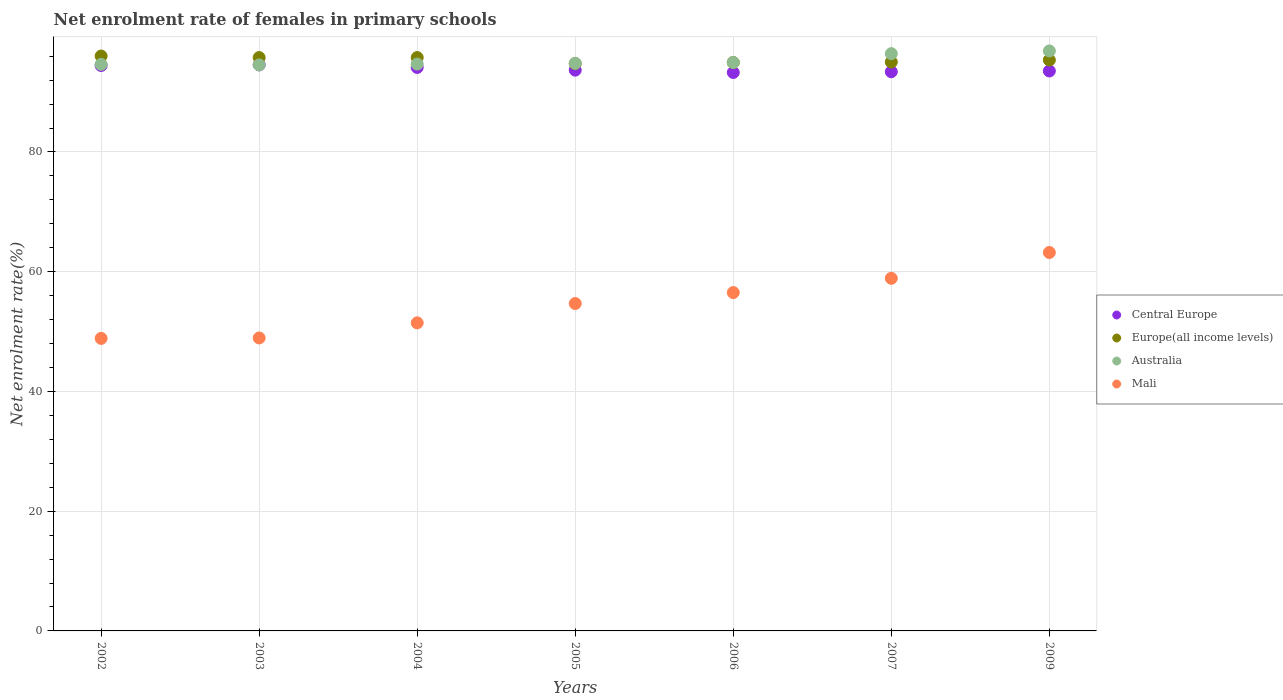How many different coloured dotlines are there?
Give a very brief answer. 4. What is the net enrolment rate of females in primary schools in Europe(all income levels) in 2007?
Give a very brief answer. 95.02. Across all years, what is the maximum net enrolment rate of females in primary schools in Australia?
Your answer should be very brief. 96.88. Across all years, what is the minimum net enrolment rate of females in primary schools in Mali?
Give a very brief answer. 48.86. In which year was the net enrolment rate of females in primary schools in Australia minimum?
Your response must be concise. 2003. What is the total net enrolment rate of females in primary schools in Mali in the graph?
Provide a short and direct response. 382.57. What is the difference between the net enrolment rate of females in primary schools in Central Europe in 2003 and that in 2006?
Your response must be concise. 1.27. What is the difference between the net enrolment rate of females in primary schools in Europe(all income levels) in 2004 and the net enrolment rate of females in primary schools in Australia in 2007?
Provide a short and direct response. -0.65. What is the average net enrolment rate of females in primary schools in Central Europe per year?
Keep it short and to the point. 93.86. In the year 2007, what is the difference between the net enrolment rate of females in primary schools in Central Europe and net enrolment rate of females in primary schools in Australia?
Make the answer very short. -3.02. In how many years, is the net enrolment rate of females in primary schools in Mali greater than 80 %?
Provide a short and direct response. 0. What is the ratio of the net enrolment rate of females in primary schools in Europe(all income levels) in 2005 to that in 2006?
Offer a very short reply. 1. What is the difference between the highest and the second highest net enrolment rate of females in primary schools in Mali?
Provide a succinct answer. 4.31. What is the difference between the highest and the lowest net enrolment rate of females in primary schools in Mali?
Keep it short and to the point. 14.35. Is it the case that in every year, the sum of the net enrolment rate of females in primary schools in Mali and net enrolment rate of females in primary schools in Australia  is greater than the sum of net enrolment rate of females in primary schools in Europe(all income levels) and net enrolment rate of females in primary schools in Central Europe?
Make the answer very short. No. Does the net enrolment rate of females in primary schools in Europe(all income levels) monotonically increase over the years?
Keep it short and to the point. No. How many dotlines are there?
Provide a short and direct response. 4. How many years are there in the graph?
Your answer should be very brief. 7. How many legend labels are there?
Give a very brief answer. 4. How are the legend labels stacked?
Offer a very short reply. Vertical. What is the title of the graph?
Offer a very short reply. Net enrolment rate of females in primary schools. What is the label or title of the X-axis?
Provide a short and direct response. Years. What is the label or title of the Y-axis?
Your answer should be very brief. Net enrolment rate(%). What is the Net enrolment rate(%) of Central Europe in 2002?
Offer a terse response. 94.44. What is the Net enrolment rate(%) in Europe(all income levels) in 2002?
Provide a succinct answer. 96.03. What is the Net enrolment rate(%) of Australia in 2002?
Your response must be concise. 94.64. What is the Net enrolment rate(%) of Mali in 2002?
Give a very brief answer. 48.86. What is the Net enrolment rate(%) in Central Europe in 2003?
Provide a succinct answer. 94.55. What is the Net enrolment rate(%) in Europe(all income levels) in 2003?
Your answer should be compact. 95.77. What is the Net enrolment rate(%) of Australia in 2003?
Keep it short and to the point. 94.54. What is the Net enrolment rate(%) of Mali in 2003?
Offer a terse response. 48.93. What is the Net enrolment rate(%) of Central Europe in 2004?
Provide a succinct answer. 94.12. What is the Net enrolment rate(%) of Europe(all income levels) in 2004?
Your response must be concise. 95.78. What is the Net enrolment rate(%) in Australia in 2004?
Offer a very short reply. 94.69. What is the Net enrolment rate(%) in Mali in 2004?
Provide a succinct answer. 51.46. What is the Net enrolment rate(%) in Central Europe in 2005?
Provide a succinct answer. 93.67. What is the Net enrolment rate(%) in Europe(all income levels) in 2005?
Your answer should be compact. 94.78. What is the Net enrolment rate(%) in Australia in 2005?
Keep it short and to the point. 94.81. What is the Net enrolment rate(%) in Mali in 2005?
Your response must be concise. 54.69. What is the Net enrolment rate(%) in Central Europe in 2006?
Offer a terse response. 93.28. What is the Net enrolment rate(%) in Europe(all income levels) in 2006?
Give a very brief answer. 94.96. What is the Net enrolment rate(%) in Australia in 2006?
Your answer should be compact. 94.95. What is the Net enrolment rate(%) of Mali in 2006?
Offer a very short reply. 56.52. What is the Net enrolment rate(%) of Central Europe in 2007?
Provide a succinct answer. 93.4. What is the Net enrolment rate(%) in Europe(all income levels) in 2007?
Your answer should be compact. 95.02. What is the Net enrolment rate(%) in Australia in 2007?
Provide a short and direct response. 96.43. What is the Net enrolment rate(%) of Mali in 2007?
Offer a terse response. 58.9. What is the Net enrolment rate(%) of Central Europe in 2009?
Provide a succinct answer. 93.53. What is the Net enrolment rate(%) of Europe(all income levels) in 2009?
Your response must be concise. 95.35. What is the Net enrolment rate(%) of Australia in 2009?
Your response must be concise. 96.88. What is the Net enrolment rate(%) of Mali in 2009?
Keep it short and to the point. 63.21. Across all years, what is the maximum Net enrolment rate(%) in Central Europe?
Make the answer very short. 94.55. Across all years, what is the maximum Net enrolment rate(%) in Europe(all income levels)?
Offer a terse response. 96.03. Across all years, what is the maximum Net enrolment rate(%) of Australia?
Offer a terse response. 96.88. Across all years, what is the maximum Net enrolment rate(%) of Mali?
Keep it short and to the point. 63.21. Across all years, what is the minimum Net enrolment rate(%) in Central Europe?
Offer a very short reply. 93.28. Across all years, what is the minimum Net enrolment rate(%) of Europe(all income levels)?
Give a very brief answer. 94.78. Across all years, what is the minimum Net enrolment rate(%) of Australia?
Provide a short and direct response. 94.54. Across all years, what is the minimum Net enrolment rate(%) of Mali?
Make the answer very short. 48.86. What is the total Net enrolment rate(%) of Central Europe in the graph?
Ensure brevity in your answer.  656.99. What is the total Net enrolment rate(%) in Europe(all income levels) in the graph?
Your answer should be compact. 667.68. What is the total Net enrolment rate(%) of Australia in the graph?
Provide a short and direct response. 666.92. What is the total Net enrolment rate(%) of Mali in the graph?
Your response must be concise. 382.57. What is the difference between the Net enrolment rate(%) in Central Europe in 2002 and that in 2003?
Offer a very short reply. -0.11. What is the difference between the Net enrolment rate(%) in Europe(all income levels) in 2002 and that in 2003?
Your answer should be very brief. 0.26. What is the difference between the Net enrolment rate(%) in Australia in 2002 and that in 2003?
Your response must be concise. 0.1. What is the difference between the Net enrolment rate(%) in Mali in 2002 and that in 2003?
Provide a succinct answer. -0.07. What is the difference between the Net enrolment rate(%) in Central Europe in 2002 and that in 2004?
Ensure brevity in your answer.  0.32. What is the difference between the Net enrolment rate(%) in Europe(all income levels) in 2002 and that in 2004?
Provide a short and direct response. 0.25. What is the difference between the Net enrolment rate(%) in Australia in 2002 and that in 2004?
Your response must be concise. -0.05. What is the difference between the Net enrolment rate(%) in Mali in 2002 and that in 2004?
Your response must be concise. -2.6. What is the difference between the Net enrolment rate(%) in Central Europe in 2002 and that in 2005?
Make the answer very short. 0.77. What is the difference between the Net enrolment rate(%) of Europe(all income levels) in 2002 and that in 2005?
Your answer should be compact. 1.25. What is the difference between the Net enrolment rate(%) of Australia in 2002 and that in 2005?
Keep it short and to the point. -0.17. What is the difference between the Net enrolment rate(%) in Mali in 2002 and that in 2005?
Your answer should be compact. -5.82. What is the difference between the Net enrolment rate(%) of Central Europe in 2002 and that in 2006?
Offer a terse response. 1.16. What is the difference between the Net enrolment rate(%) of Europe(all income levels) in 2002 and that in 2006?
Provide a succinct answer. 1.07. What is the difference between the Net enrolment rate(%) in Australia in 2002 and that in 2006?
Provide a succinct answer. -0.31. What is the difference between the Net enrolment rate(%) in Mali in 2002 and that in 2006?
Your answer should be very brief. -7.65. What is the difference between the Net enrolment rate(%) in Central Europe in 2002 and that in 2007?
Provide a short and direct response. 1.04. What is the difference between the Net enrolment rate(%) in Australia in 2002 and that in 2007?
Provide a short and direct response. -1.79. What is the difference between the Net enrolment rate(%) of Mali in 2002 and that in 2007?
Your answer should be compact. -10.04. What is the difference between the Net enrolment rate(%) in Central Europe in 2002 and that in 2009?
Your answer should be compact. 0.92. What is the difference between the Net enrolment rate(%) of Europe(all income levels) in 2002 and that in 2009?
Your answer should be compact. 0.67. What is the difference between the Net enrolment rate(%) in Australia in 2002 and that in 2009?
Provide a short and direct response. -2.24. What is the difference between the Net enrolment rate(%) of Mali in 2002 and that in 2009?
Your response must be concise. -14.35. What is the difference between the Net enrolment rate(%) of Central Europe in 2003 and that in 2004?
Your answer should be compact. 0.43. What is the difference between the Net enrolment rate(%) of Europe(all income levels) in 2003 and that in 2004?
Your answer should be compact. -0. What is the difference between the Net enrolment rate(%) of Australia in 2003 and that in 2004?
Give a very brief answer. -0.14. What is the difference between the Net enrolment rate(%) of Mali in 2003 and that in 2004?
Provide a succinct answer. -2.52. What is the difference between the Net enrolment rate(%) of Central Europe in 2003 and that in 2005?
Provide a short and direct response. 0.88. What is the difference between the Net enrolment rate(%) of Australia in 2003 and that in 2005?
Keep it short and to the point. -0.27. What is the difference between the Net enrolment rate(%) in Mali in 2003 and that in 2005?
Provide a succinct answer. -5.75. What is the difference between the Net enrolment rate(%) in Central Europe in 2003 and that in 2006?
Provide a succinct answer. 1.27. What is the difference between the Net enrolment rate(%) in Europe(all income levels) in 2003 and that in 2006?
Make the answer very short. 0.81. What is the difference between the Net enrolment rate(%) in Australia in 2003 and that in 2006?
Offer a terse response. -0.41. What is the difference between the Net enrolment rate(%) in Mali in 2003 and that in 2006?
Your response must be concise. -7.58. What is the difference between the Net enrolment rate(%) of Central Europe in 2003 and that in 2007?
Keep it short and to the point. 1.14. What is the difference between the Net enrolment rate(%) of Europe(all income levels) in 2003 and that in 2007?
Provide a short and direct response. 0.75. What is the difference between the Net enrolment rate(%) of Australia in 2003 and that in 2007?
Give a very brief answer. -1.88. What is the difference between the Net enrolment rate(%) of Mali in 2003 and that in 2007?
Ensure brevity in your answer.  -9.96. What is the difference between the Net enrolment rate(%) of Central Europe in 2003 and that in 2009?
Make the answer very short. 1.02. What is the difference between the Net enrolment rate(%) of Europe(all income levels) in 2003 and that in 2009?
Offer a very short reply. 0.42. What is the difference between the Net enrolment rate(%) of Australia in 2003 and that in 2009?
Keep it short and to the point. -2.33. What is the difference between the Net enrolment rate(%) of Mali in 2003 and that in 2009?
Your response must be concise. -14.28. What is the difference between the Net enrolment rate(%) of Central Europe in 2004 and that in 2005?
Your response must be concise. 0.45. What is the difference between the Net enrolment rate(%) in Europe(all income levels) in 2004 and that in 2005?
Your answer should be very brief. 1. What is the difference between the Net enrolment rate(%) of Australia in 2004 and that in 2005?
Offer a terse response. -0.12. What is the difference between the Net enrolment rate(%) of Mali in 2004 and that in 2005?
Your answer should be compact. -3.23. What is the difference between the Net enrolment rate(%) in Central Europe in 2004 and that in 2006?
Ensure brevity in your answer.  0.84. What is the difference between the Net enrolment rate(%) in Europe(all income levels) in 2004 and that in 2006?
Offer a terse response. 0.82. What is the difference between the Net enrolment rate(%) of Australia in 2004 and that in 2006?
Your answer should be very brief. -0.26. What is the difference between the Net enrolment rate(%) of Mali in 2004 and that in 2006?
Give a very brief answer. -5.06. What is the difference between the Net enrolment rate(%) of Central Europe in 2004 and that in 2007?
Offer a terse response. 0.72. What is the difference between the Net enrolment rate(%) in Europe(all income levels) in 2004 and that in 2007?
Provide a succinct answer. 0.75. What is the difference between the Net enrolment rate(%) of Australia in 2004 and that in 2007?
Provide a short and direct response. -1.74. What is the difference between the Net enrolment rate(%) of Mali in 2004 and that in 2007?
Make the answer very short. -7.44. What is the difference between the Net enrolment rate(%) of Central Europe in 2004 and that in 2009?
Offer a very short reply. 0.59. What is the difference between the Net enrolment rate(%) in Europe(all income levels) in 2004 and that in 2009?
Offer a very short reply. 0.42. What is the difference between the Net enrolment rate(%) of Australia in 2004 and that in 2009?
Provide a short and direct response. -2.19. What is the difference between the Net enrolment rate(%) of Mali in 2004 and that in 2009?
Make the answer very short. -11.75. What is the difference between the Net enrolment rate(%) in Central Europe in 2005 and that in 2006?
Make the answer very short. 0.39. What is the difference between the Net enrolment rate(%) of Europe(all income levels) in 2005 and that in 2006?
Your answer should be compact. -0.18. What is the difference between the Net enrolment rate(%) in Australia in 2005 and that in 2006?
Make the answer very short. -0.14. What is the difference between the Net enrolment rate(%) in Mali in 2005 and that in 2006?
Ensure brevity in your answer.  -1.83. What is the difference between the Net enrolment rate(%) of Central Europe in 2005 and that in 2007?
Offer a terse response. 0.26. What is the difference between the Net enrolment rate(%) in Europe(all income levels) in 2005 and that in 2007?
Offer a terse response. -0.25. What is the difference between the Net enrolment rate(%) in Australia in 2005 and that in 2007?
Offer a very short reply. -1.62. What is the difference between the Net enrolment rate(%) of Mali in 2005 and that in 2007?
Your answer should be compact. -4.21. What is the difference between the Net enrolment rate(%) in Central Europe in 2005 and that in 2009?
Your response must be concise. 0.14. What is the difference between the Net enrolment rate(%) in Europe(all income levels) in 2005 and that in 2009?
Offer a terse response. -0.58. What is the difference between the Net enrolment rate(%) in Australia in 2005 and that in 2009?
Your answer should be compact. -2.07. What is the difference between the Net enrolment rate(%) in Mali in 2005 and that in 2009?
Offer a very short reply. -8.52. What is the difference between the Net enrolment rate(%) in Central Europe in 2006 and that in 2007?
Your answer should be very brief. -0.13. What is the difference between the Net enrolment rate(%) of Europe(all income levels) in 2006 and that in 2007?
Your response must be concise. -0.07. What is the difference between the Net enrolment rate(%) of Australia in 2006 and that in 2007?
Your answer should be compact. -1.48. What is the difference between the Net enrolment rate(%) in Mali in 2006 and that in 2007?
Ensure brevity in your answer.  -2.38. What is the difference between the Net enrolment rate(%) of Central Europe in 2006 and that in 2009?
Provide a succinct answer. -0.25. What is the difference between the Net enrolment rate(%) of Europe(all income levels) in 2006 and that in 2009?
Offer a very short reply. -0.4. What is the difference between the Net enrolment rate(%) in Australia in 2006 and that in 2009?
Provide a succinct answer. -1.93. What is the difference between the Net enrolment rate(%) of Mali in 2006 and that in 2009?
Offer a terse response. -6.69. What is the difference between the Net enrolment rate(%) of Central Europe in 2007 and that in 2009?
Your response must be concise. -0.12. What is the difference between the Net enrolment rate(%) of Europe(all income levels) in 2007 and that in 2009?
Your response must be concise. -0.33. What is the difference between the Net enrolment rate(%) in Australia in 2007 and that in 2009?
Your answer should be very brief. -0.45. What is the difference between the Net enrolment rate(%) in Mali in 2007 and that in 2009?
Offer a very short reply. -4.31. What is the difference between the Net enrolment rate(%) of Central Europe in 2002 and the Net enrolment rate(%) of Europe(all income levels) in 2003?
Provide a short and direct response. -1.33. What is the difference between the Net enrolment rate(%) of Central Europe in 2002 and the Net enrolment rate(%) of Australia in 2003?
Provide a short and direct response. -0.1. What is the difference between the Net enrolment rate(%) in Central Europe in 2002 and the Net enrolment rate(%) in Mali in 2003?
Ensure brevity in your answer.  45.51. What is the difference between the Net enrolment rate(%) in Europe(all income levels) in 2002 and the Net enrolment rate(%) in Australia in 2003?
Provide a short and direct response. 1.49. What is the difference between the Net enrolment rate(%) in Europe(all income levels) in 2002 and the Net enrolment rate(%) in Mali in 2003?
Provide a short and direct response. 47.09. What is the difference between the Net enrolment rate(%) of Australia in 2002 and the Net enrolment rate(%) of Mali in 2003?
Give a very brief answer. 45.7. What is the difference between the Net enrolment rate(%) of Central Europe in 2002 and the Net enrolment rate(%) of Europe(all income levels) in 2004?
Offer a very short reply. -1.33. What is the difference between the Net enrolment rate(%) of Central Europe in 2002 and the Net enrolment rate(%) of Australia in 2004?
Provide a succinct answer. -0.24. What is the difference between the Net enrolment rate(%) of Central Europe in 2002 and the Net enrolment rate(%) of Mali in 2004?
Your response must be concise. 42.98. What is the difference between the Net enrolment rate(%) in Europe(all income levels) in 2002 and the Net enrolment rate(%) in Australia in 2004?
Your answer should be very brief. 1.34. What is the difference between the Net enrolment rate(%) in Europe(all income levels) in 2002 and the Net enrolment rate(%) in Mali in 2004?
Your response must be concise. 44.57. What is the difference between the Net enrolment rate(%) of Australia in 2002 and the Net enrolment rate(%) of Mali in 2004?
Provide a succinct answer. 43.18. What is the difference between the Net enrolment rate(%) of Central Europe in 2002 and the Net enrolment rate(%) of Europe(all income levels) in 2005?
Your response must be concise. -0.33. What is the difference between the Net enrolment rate(%) of Central Europe in 2002 and the Net enrolment rate(%) of Australia in 2005?
Ensure brevity in your answer.  -0.36. What is the difference between the Net enrolment rate(%) of Central Europe in 2002 and the Net enrolment rate(%) of Mali in 2005?
Provide a succinct answer. 39.76. What is the difference between the Net enrolment rate(%) in Europe(all income levels) in 2002 and the Net enrolment rate(%) in Australia in 2005?
Offer a terse response. 1.22. What is the difference between the Net enrolment rate(%) of Europe(all income levels) in 2002 and the Net enrolment rate(%) of Mali in 2005?
Offer a terse response. 41.34. What is the difference between the Net enrolment rate(%) in Australia in 2002 and the Net enrolment rate(%) in Mali in 2005?
Ensure brevity in your answer.  39.95. What is the difference between the Net enrolment rate(%) of Central Europe in 2002 and the Net enrolment rate(%) of Europe(all income levels) in 2006?
Make the answer very short. -0.51. What is the difference between the Net enrolment rate(%) in Central Europe in 2002 and the Net enrolment rate(%) in Australia in 2006?
Offer a terse response. -0.5. What is the difference between the Net enrolment rate(%) in Central Europe in 2002 and the Net enrolment rate(%) in Mali in 2006?
Your answer should be very brief. 37.93. What is the difference between the Net enrolment rate(%) in Europe(all income levels) in 2002 and the Net enrolment rate(%) in Australia in 2006?
Offer a very short reply. 1.08. What is the difference between the Net enrolment rate(%) of Europe(all income levels) in 2002 and the Net enrolment rate(%) of Mali in 2006?
Your answer should be compact. 39.51. What is the difference between the Net enrolment rate(%) of Australia in 2002 and the Net enrolment rate(%) of Mali in 2006?
Your answer should be compact. 38.12. What is the difference between the Net enrolment rate(%) of Central Europe in 2002 and the Net enrolment rate(%) of Europe(all income levels) in 2007?
Keep it short and to the point. -0.58. What is the difference between the Net enrolment rate(%) of Central Europe in 2002 and the Net enrolment rate(%) of Australia in 2007?
Keep it short and to the point. -1.98. What is the difference between the Net enrolment rate(%) in Central Europe in 2002 and the Net enrolment rate(%) in Mali in 2007?
Your answer should be compact. 35.55. What is the difference between the Net enrolment rate(%) of Europe(all income levels) in 2002 and the Net enrolment rate(%) of Australia in 2007?
Provide a short and direct response. -0.4. What is the difference between the Net enrolment rate(%) in Europe(all income levels) in 2002 and the Net enrolment rate(%) in Mali in 2007?
Provide a short and direct response. 37.13. What is the difference between the Net enrolment rate(%) of Australia in 2002 and the Net enrolment rate(%) of Mali in 2007?
Your answer should be compact. 35.74. What is the difference between the Net enrolment rate(%) of Central Europe in 2002 and the Net enrolment rate(%) of Europe(all income levels) in 2009?
Offer a terse response. -0.91. What is the difference between the Net enrolment rate(%) of Central Europe in 2002 and the Net enrolment rate(%) of Australia in 2009?
Give a very brief answer. -2.43. What is the difference between the Net enrolment rate(%) of Central Europe in 2002 and the Net enrolment rate(%) of Mali in 2009?
Offer a very short reply. 31.23. What is the difference between the Net enrolment rate(%) of Europe(all income levels) in 2002 and the Net enrolment rate(%) of Australia in 2009?
Make the answer very short. -0.85. What is the difference between the Net enrolment rate(%) of Europe(all income levels) in 2002 and the Net enrolment rate(%) of Mali in 2009?
Your answer should be very brief. 32.82. What is the difference between the Net enrolment rate(%) in Australia in 2002 and the Net enrolment rate(%) in Mali in 2009?
Give a very brief answer. 31.43. What is the difference between the Net enrolment rate(%) in Central Europe in 2003 and the Net enrolment rate(%) in Europe(all income levels) in 2004?
Your answer should be compact. -1.23. What is the difference between the Net enrolment rate(%) of Central Europe in 2003 and the Net enrolment rate(%) of Australia in 2004?
Your answer should be compact. -0.14. What is the difference between the Net enrolment rate(%) in Central Europe in 2003 and the Net enrolment rate(%) in Mali in 2004?
Make the answer very short. 43.09. What is the difference between the Net enrolment rate(%) of Europe(all income levels) in 2003 and the Net enrolment rate(%) of Australia in 2004?
Offer a terse response. 1.09. What is the difference between the Net enrolment rate(%) in Europe(all income levels) in 2003 and the Net enrolment rate(%) in Mali in 2004?
Your response must be concise. 44.31. What is the difference between the Net enrolment rate(%) in Australia in 2003 and the Net enrolment rate(%) in Mali in 2004?
Your answer should be very brief. 43.08. What is the difference between the Net enrolment rate(%) in Central Europe in 2003 and the Net enrolment rate(%) in Europe(all income levels) in 2005?
Offer a very short reply. -0.23. What is the difference between the Net enrolment rate(%) in Central Europe in 2003 and the Net enrolment rate(%) in Australia in 2005?
Give a very brief answer. -0.26. What is the difference between the Net enrolment rate(%) of Central Europe in 2003 and the Net enrolment rate(%) of Mali in 2005?
Ensure brevity in your answer.  39.86. What is the difference between the Net enrolment rate(%) of Europe(all income levels) in 2003 and the Net enrolment rate(%) of Australia in 2005?
Give a very brief answer. 0.96. What is the difference between the Net enrolment rate(%) of Europe(all income levels) in 2003 and the Net enrolment rate(%) of Mali in 2005?
Make the answer very short. 41.08. What is the difference between the Net enrolment rate(%) in Australia in 2003 and the Net enrolment rate(%) in Mali in 2005?
Provide a succinct answer. 39.85. What is the difference between the Net enrolment rate(%) in Central Europe in 2003 and the Net enrolment rate(%) in Europe(all income levels) in 2006?
Keep it short and to the point. -0.41. What is the difference between the Net enrolment rate(%) in Central Europe in 2003 and the Net enrolment rate(%) in Australia in 2006?
Give a very brief answer. -0.4. What is the difference between the Net enrolment rate(%) in Central Europe in 2003 and the Net enrolment rate(%) in Mali in 2006?
Provide a succinct answer. 38.03. What is the difference between the Net enrolment rate(%) of Europe(all income levels) in 2003 and the Net enrolment rate(%) of Australia in 2006?
Provide a short and direct response. 0.82. What is the difference between the Net enrolment rate(%) in Europe(all income levels) in 2003 and the Net enrolment rate(%) in Mali in 2006?
Your response must be concise. 39.25. What is the difference between the Net enrolment rate(%) of Australia in 2003 and the Net enrolment rate(%) of Mali in 2006?
Make the answer very short. 38.03. What is the difference between the Net enrolment rate(%) in Central Europe in 2003 and the Net enrolment rate(%) in Europe(all income levels) in 2007?
Offer a terse response. -0.48. What is the difference between the Net enrolment rate(%) in Central Europe in 2003 and the Net enrolment rate(%) in Australia in 2007?
Offer a very short reply. -1.88. What is the difference between the Net enrolment rate(%) in Central Europe in 2003 and the Net enrolment rate(%) in Mali in 2007?
Make the answer very short. 35.65. What is the difference between the Net enrolment rate(%) in Europe(all income levels) in 2003 and the Net enrolment rate(%) in Australia in 2007?
Give a very brief answer. -0.65. What is the difference between the Net enrolment rate(%) in Europe(all income levels) in 2003 and the Net enrolment rate(%) in Mali in 2007?
Keep it short and to the point. 36.87. What is the difference between the Net enrolment rate(%) of Australia in 2003 and the Net enrolment rate(%) of Mali in 2007?
Provide a succinct answer. 35.64. What is the difference between the Net enrolment rate(%) of Central Europe in 2003 and the Net enrolment rate(%) of Europe(all income levels) in 2009?
Offer a terse response. -0.81. What is the difference between the Net enrolment rate(%) in Central Europe in 2003 and the Net enrolment rate(%) in Australia in 2009?
Make the answer very short. -2.33. What is the difference between the Net enrolment rate(%) of Central Europe in 2003 and the Net enrolment rate(%) of Mali in 2009?
Your response must be concise. 31.34. What is the difference between the Net enrolment rate(%) in Europe(all income levels) in 2003 and the Net enrolment rate(%) in Australia in 2009?
Your answer should be very brief. -1.1. What is the difference between the Net enrolment rate(%) in Europe(all income levels) in 2003 and the Net enrolment rate(%) in Mali in 2009?
Your answer should be very brief. 32.56. What is the difference between the Net enrolment rate(%) of Australia in 2003 and the Net enrolment rate(%) of Mali in 2009?
Your answer should be very brief. 31.33. What is the difference between the Net enrolment rate(%) in Central Europe in 2004 and the Net enrolment rate(%) in Europe(all income levels) in 2005?
Ensure brevity in your answer.  -0.66. What is the difference between the Net enrolment rate(%) in Central Europe in 2004 and the Net enrolment rate(%) in Australia in 2005?
Provide a succinct answer. -0.69. What is the difference between the Net enrolment rate(%) in Central Europe in 2004 and the Net enrolment rate(%) in Mali in 2005?
Make the answer very short. 39.43. What is the difference between the Net enrolment rate(%) of Europe(all income levels) in 2004 and the Net enrolment rate(%) of Australia in 2005?
Make the answer very short. 0.97. What is the difference between the Net enrolment rate(%) of Europe(all income levels) in 2004 and the Net enrolment rate(%) of Mali in 2005?
Your answer should be compact. 41.09. What is the difference between the Net enrolment rate(%) of Australia in 2004 and the Net enrolment rate(%) of Mali in 2005?
Your answer should be very brief. 40. What is the difference between the Net enrolment rate(%) of Central Europe in 2004 and the Net enrolment rate(%) of Europe(all income levels) in 2006?
Your answer should be compact. -0.84. What is the difference between the Net enrolment rate(%) in Central Europe in 2004 and the Net enrolment rate(%) in Australia in 2006?
Offer a terse response. -0.83. What is the difference between the Net enrolment rate(%) of Central Europe in 2004 and the Net enrolment rate(%) of Mali in 2006?
Offer a very short reply. 37.6. What is the difference between the Net enrolment rate(%) of Europe(all income levels) in 2004 and the Net enrolment rate(%) of Australia in 2006?
Provide a short and direct response. 0.83. What is the difference between the Net enrolment rate(%) of Europe(all income levels) in 2004 and the Net enrolment rate(%) of Mali in 2006?
Offer a terse response. 39.26. What is the difference between the Net enrolment rate(%) in Australia in 2004 and the Net enrolment rate(%) in Mali in 2006?
Offer a very short reply. 38.17. What is the difference between the Net enrolment rate(%) in Central Europe in 2004 and the Net enrolment rate(%) in Europe(all income levels) in 2007?
Your answer should be very brief. -0.9. What is the difference between the Net enrolment rate(%) in Central Europe in 2004 and the Net enrolment rate(%) in Australia in 2007?
Offer a very short reply. -2.31. What is the difference between the Net enrolment rate(%) in Central Europe in 2004 and the Net enrolment rate(%) in Mali in 2007?
Ensure brevity in your answer.  35.22. What is the difference between the Net enrolment rate(%) in Europe(all income levels) in 2004 and the Net enrolment rate(%) in Australia in 2007?
Provide a short and direct response. -0.65. What is the difference between the Net enrolment rate(%) in Europe(all income levels) in 2004 and the Net enrolment rate(%) in Mali in 2007?
Offer a very short reply. 36.88. What is the difference between the Net enrolment rate(%) in Australia in 2004 and the Net enrolment rate(%) in Mali in 2007?
Provide a succinct answer. 35.79. What is the difference between the Net enrolment rate(%) in Central Europe in 2004 and the Net enrolment rate(%) in Europe(all income levels) in 2009?
Give a very brief answer. -1.23. What is the difference between the Net enrolment rate(%) in Central Europe in 2004 and the Net enrolment rate(%) in Australia in 2009?
Give a very brief answer. -2.76. What is the difference between the Net enrolment rate(%) of Central Europe in 2004 and the Net enrolment rate(%) of Mali in 2009?
Provide a succinct answer. 30.91. What is the difference between the Net enrolment rate(%) in Europe(all income levels) in 2004 and the Net enrolment rate(%) in Australia in 2009?
Provide a short and direct response. -1.1. What is the difference between the Net enrolment rate(%) of Europe(all income levels) in 2004 and the Net enrolment rate(%) of Mali in 2009?
Provide a short and direct response. 32.56. What is the difference between the Net enrolment rate(%) in Australia in 2004 and the Net enrolment rate(%) in Mali in 2009?
Provide a short and direct response. 31.47. What is the difference between the Net enrolment rate(%) in Central Europe in 2005 and the Net enrolment rate(%) in Europe(all income levels) in 2006?
Provide a succinct answer. -1.29. What is the difference between the Net enrolment rate(%) of Central Europe in 2005 and the Net enrolment rate(%) of Australia in 2006?
Your answer should be very brief. -1.28. What is the difference between the Net enrolment rate(%) of Central Europe in 2005 and the Net enrolment rate(%) of Mali in 2006?
Provide a short and direct response. 37.15. What is the difference between the Net enrolment rate(%) in Europe(all income levels) in 2005 and the Net enrolment rate(%) in Australia in 2006?
Provide a short and direct response. -0.17. What is the difference between the Net enrolment rate(%) in Europe(all income levels) in 2005 and the Net enrolment rate(%) in Mali in 2006?
Your response must be concise. 38.26. What is the difference between the Net enrolment rate(%) of Australia in 2005 and the Net enrolment rate(%) of Mali in 2006?
Ensure brevity in your answer.  38.29. What is the difference between the Net enrolment rate(%) of Central Europe in 2005 and the Net enrolment rate(%) of Europe(all income levels) in 2007?
Give a very brief answer. -1.36. What is the difference between the Net enrolment rate(%) in Central Europe in 2005 and the Net enrolment rate(%) in Australia in 2007?
Make the answer very short. -2.76. What is the difference between the Net enrolment rate(%) in Central Europe in 2005 and the Net enrolment rate(%) in Mali in 2007?
Keep it short and to the point. 34.77. What is the difference between the Net enrolment rate(%) in Europe(all income levels) in 2005 and the Net enrolment rate(%) in Australia in 2007?
Give a very brief answer. -1.65. What is the difference between the Net enrolment rate(%) in Europe(all income levels) in 2005 and the Net enrolment rate(%) in Mali in 2007?
Provide a succinct answer. 35.88. What is the difference between the Net enrolment rate(%) in Australia in 2005 and the Net enrolment rate(%) in Mali in 2007?
Offer a very short reply. 35.91. What is the difference between the Net enrolment rate(%) in Central Europe in 2005 and the Net enrolment rate(%) in Europe(all income levels) in 2009?
Keep it short and to the point. -1.69. What is the difference between the Net enrolment rate(%) of Central Europe in 2005 and the Net enrolment rate(%) of Australia in 2009?
Your answer should be compact. -3.21. What is the difference between the Net enrolment rate(%) of Central Europe in 2005 and the Net enrolment rate(%) of Mali in 2009?
Provide a succinct answer. 30.46. What is the difference between the Net enrolment rate(%) in Europe(all income levels) in 2005 and the Net enrolment rate(%) in Australia in 2009?
Provide a succinct answer. -2.1. What is the difference between the Net enrolment rate(%) of Europe(all income levels) in 2005 and the Net enrolment rate(%) of Mali in 2009?
Your answer should be compact. 31.56. What is the difference between the Net enrolment rate(%) of Australia in 2005 and the Net enrolment rate(%) of Mali in 2009?
Provide a short and direct response. 31.6. What is the difference between the Net enrolment rate(%) of Central Europe in 2006 and the Net enrolment rate(%) of Europe(all income levels) in 2007?
Keep it short and to the point. -1.75. What is the difference between the Net enrolment rate(%) of Central Europe in 2006 and the Net enrolment rate(%) of Australia in 2007?
Offer a terse response. -3.15. What is the difference between the Net enrolment rate(%) of Central Europe in 2006 and the Net enrolment rate(%) of Mali in 2007?
Make the answer very short. 34.38. What is the difference between the Net enrolment rate(%) in Europe(all income levels) in 2006 and the Net enrolment rate(%) in Australia in 2007?
Your answer should be very brief. -1.47. What is the difference between the Net enrolment rate(%) in Europe(all income levels) in 2006 and the Net enrolment rate(%) in Mali in 2007?
Keep it short and to the point. 36.06. What is the difference between the Net enrolment rate(%) of Australia in 2006 and the Net enrolment rate(%) of Mali in 2007?
Your answer should be very brief. 36.05. What is the difference between the Net enrolment rate(%) of Central Europe in 2006 and the Net enrolment rate(%) of Europe(all income levels) in 2009?
Offer a very short reply. -2.08. What is the difference between the Net enrolment rate(%) in Central Europe in 2006 and the Net enrolment rate(%) in Australia in 2009?
Ensure brevity in your answer.  -3.6. What is the difference between the Net enrolment rate(%) of Central Europe in 2006 and the Net enrolment rate(%) of Mali in 2009?
Your answer should be very brief. 30.07. What is the difference between the Net enrolment rate(%) of Europe(all income levels) in 2006 and the Net enrolment rate(%) of Australia in 2009?
Ensure brevity in your answer.  -1.92. What is the difference between the Net enrolment rate(%) in Europe(all income levels) in 2006 and the Net enrolment rate(%) in Mali in 2009?
Offer a very short reply. 31.75. What is the difference between the Net enrolment rate(%) of Australia in 2006 and the Net enrolment rate(%) of Mali in 2009?
Your answer should be compact. 31.74. What is the difference between the Net enrolment rate(%) in Central Europe in 2007 and the Net enrolment rate(%) in Europe(all income levels) in 2009?
Your answer should be very brief. -1.95. What is the difference between the Net enrolment rate(%) of Central Europe in 2007 and the Net enrolment rate(%) of Australia in 2009?
Your answer should be very brief. -3.47. What is the difference between the Net enrolment rate(%) in Central Europe in 2007 and the Net enrolment rate(%) in Mali in 2009?
Offer a terse response. 30.19. What is the difference between the Net enrolment rate(%) in Europe(all income levels) in 2007 and the Net enrolment rate(%) in Australia in 2009?
Provide a succinct answer. -1.85. What is the difference between the Net enrolment rate(%) of Europe(all income levels) in 2007 and the Net enrolment rate(%) of Mali in 2009?
Provide a short and direct response. 31.81. What is the difference between the Net enrolment rate(%) of Australia in 2007 and the Net enrolment rate(%) of Mali in 2009?
Ensure brevity in your answer.  33.21. What is the average Net enrolment rate(%) of Central Europe per year?
Offer a very short reply. 93.86. What is the average Net enrolment rate(%) in Europe(all income levels) per year?
Offer a very short reply. 95.38. What is the average Net enrolment rate(%) in Australia per year?
Give a very brief answer. 95.27. What is the average Net enrolment rate(%) in Mali per year?
Give a very brief answer. 54.65. In the year 2002, what is the difference between the Net enrolment rate(%) of Central Europe and Net enrolment rate(%) of Europe(all income levels)?
Make the answer very short. -1.59. In the year 2002, what is the difference between the Net enrolment rate(%) in Central Europe and Net enrolment rate(%) in Australia?
Keep it short and to the point. -0.2. In the year 2002, what is the difference between the Net enrolment rate(%) in Central Europe and Net enrolment rate(%) in Mali?
Your answer should be compact. 45.58. In the year 2002, what is the difference between the Net enrolment rate(%) in Europe(all income levels) and Net enrolment rate(%) in Australia?
Provide a short and direct response. 1.39. In the year 2002, what is the difference between the Net enrolment rate(%) in Europe(all income levels) and Net enrolment rate(%) in Mali?
Give a very brief answer. 47.17. In the year 2002, what is the difference between the Net enrolment rate(%) of Australia and Net enrolment rate(%) of Mali?
Keep it short and to the point. 45.78. In the year 2003, what is the difference between the Net enrolment rate(%) of Central Europe and Net enrolment rate(%) of Europe(all income levels)?
Your answer should be compact. -1.22. In the year 2003, what is the difference between the Net enrolment rate(%) in Central Europe and Net enrolment rate(%) in Australia?
Keep it short and to the point. 0.01. In the year 2003, what is the difference between the Net enrolment rate(%) in Central Europe and Net enrolment rate(%) in Mali?
Your answer should be very brief. 45.61. In the year 2003, what is the difference between the Net enrolment rate(%) in Europe(all income levels) and Net enrolment rate(%) in Australia?
Offer a terse response. 1.23. In the year 2003, what is the difference between the Net enrolment rate(%) of Europe(all income levels) and Net enrolment rate(%) of Mali?
Offer a terse response. 46.84. In the year 2003, what is the difference between the Net enrolment rate(%) in Australia and Net enrolment rate(%) in Mali?
Make the answer very short. 45.61. In the year 2004, what is the difference between the Net enrolment rate(%) of Central Europe and Net enrolment rate(%) of Europe(all income levels)?
Make the answer very short. -1.66. In the year 2004, what is the difference between the Net enrolment rate(%) of Central Europe and Net enrolment rate(%) of Australia?
Your answer should be compact. -0.57. In the year 2004, what is the difference between the Net enrolment rate(%) of Central Europe and Net enrolment rate(%) of Mali?
Offer a terse response. 42.66. In the year 2004, what is the difference between the Net enrolment rate(%) of Europe(all income levels) and Net enrolment rate(%) of Australia?
Provide a short and direct response. 1.09. In the year 2004, what is the difference between the Net enrolment rate(%) in Europe(all income levels) and Net enrolment rate(%) in Mali?
Make the answer very short. 44.32. In the year 2004, what is the difference between the Net enrolment rate(%) in Australia and Net enrolment rate(%) in Mali?
Your answer should be compact. 43.23. In the year 2005, what is the difference between the Net enrolment rate(%) in Central Europe and Net enrolment rate(%) in Europe(all income levels)?
Provide a succinct answer. -1.11. In the year 2005, what is the difference between the Net enrolment rate(%) of Central Europe and Net enrolment rate(%) of Australia?
Provide a short and direct response. -1.14. In the year 2005, what is the difference between the Net enrolment rate(%) in Central Europe and Net enrolment rate(%) in Mali?
Provide a succinct answer. 38.98. In the year 2005, what is the difference between the Net enrolment rate(%) of Europe(all income levels) and Net enrolment rate(%) of Australia?
Your response must be concise. -0.03. In the year 2005, what is the difference between the Net enrolment rate(%) of Europe(all income levels) and Net enrolment rate(%) of Mali?
Your answer should be compact. 40.09. In the year 2005, what is the difference between the Net enrolment rate(%) in Australia and Net enrolment rate(%) in Mali?
Offer a very short reply. 40.12. In the year 2006, what is the difference between the Net enrolment rate(%) of Central Europe and Net enrolment rate(%) of Europe(all income levels)?
Your answer should be very brief. -1.68. In the year 2006, what is the difference between the Net enrolment rate(%) of Central Europe and Net enrolment rate(%) of Australia?
Offer a terse response. -1.67. In the year 2006, what is the difference between the Net enrolment rate(%) of Central Europe and Net enrolment rate(%) of Mali?
Keep it short and to the point. 36.76. In the year 2006, what is the difference between the Net enrolment rate(%) of Europe(all income levels) and Net enrolment rate(%) of Australia?
Give a very brief answer. 0.01. In the year 2006, what is the difference between the Net enrolment rate(%) in Europe(all income levels) and Net enrolment rate(%) in Mali?
Your answer should be very brief. 38.44. In the year 2006, what is the difference between the Net enrolment rate(%) of Australia and Net enrolment rate(%) of Mali?
Make the answer very short. 38.43. In the year 2007, what is the difference between the Net enrolment rate(%) of Central Europe and Net enrolment rate(%) of Europe(all income levels)?
Ensure brevity in your answer.  -1.62. In the year 2007, what is the difference between the Net enrolment rate(%) in Central Europe and Net enrolment rate(%) in Australia?
Provide a short and direct response. -3.02. In the year 2007, what is the difference between the Net enrolment rate(%) of Central Europe and Net enrolment rate(%) of Mali?
Your response must be concise. 34.51. In the year 2007, what is the difference between the Net enrolment rate(%) of Europe(all income levels) and Net enrolment rate(%) of Australia?
Offer a terse response. -1.4. In the year 2007, what is the difference between the Net enrolment rate(%) in Europe(all income levels) and Net enrolment rate(%) in Mali?
Your response must be concise. 36.13. In the year 2007, what is the difference between the Net enrolment rate(%) of Australia and Net enrolment rate(%) of Mali?
Keep it short and to the point. 37.53. In the year 2009, what is the difference between the Net enrolment rate(%) of Central Europe and Net enrolment rate(%) of Europe(all income levels)?
Give a very brief answer. -1.83. In the year 2009, what is the difference between the Net enrolment rate(%) of Central Europe and Net enrolment rate(%) of Australia?
Ensure brevity in your answer.  -3.35. In the year 2009, what is the difference between the Net enrolment rate(%) in Central Europe and Net enrolment rate(%) in Mali?
Offer a very short reply. 30.32. In the year 2009, what is the difference between the Net enrolment rate(%) in Europe(all income levels) and Net enrolment rate(%) in Australia?
Provide a short and direct response. -1.52. In the year 2009, what is the difference between the Net enrolment rate(%) in Europe(all income levels) and Net enrolment rate(%) in Mali?
Make the answer very short. 32.14. In the year 2009, what is the difference between the Net enrolment rate(%) in Australia and Net enrolment rate(%) in Mali?
Make the answer very short. 33.67. What is the ratio of the Net enrolment rate(%) of Europe(all income levels) in 2002 to that in 2003?
Your answer should be compact. 1. What is the ratio of the Net enrolment rate(%) of Mali in 2002 to that in 2003?
Provide a succinct answer. 1. What is the ratio of the Net enrolment rate(%) of Europe(all income levels) in 2002 to that in 2004?
Offer a terse response. 1. What is the ratio of the Net enrolment rate(%) in Australia in 2002 to that in 2004?
Provide a succinct answer. 1. What is the ratio of the Net enrolment rate(%) in Mali in 2002 to that in 2004?
Your answer should be compact. 0.95. What is the ratio of the Net enrolment rate(%) of Central Europe in 2002 to that in 2005?
Give a very brief answer. 1.01. What is the ratio of the Net enrolment rate(%) in Europe(all income levels) in 2002 to that in 2005?
Your response must be concise. 1.01. What is the ratio of the Net enrolment rate(%) of Mali in 2002 to that in 2005?
Give a very brief answer. 0.89. What is the ratio of the Net enrolment rate(%) in Central Europe in 2002 to that in 2006?
Offer a terse response. 1.01. What is the ratio of the Net enrolment rate(%) of Europe(all income levels) in 2002 to that in 2006?
Make the answer very short. 1.01. What is the ratio of the Net enrolment rate(%) in Mali in 2002 to that in 2006?
Offer a terse response. 0.86. What is the ratio of the Net enrolment rate(%) in Central Europe in 2002 to that in 2007?
Ensure brevity in your answer.  1.01. What is the ratio of the Net enrolment rate(%) in Europe(all income levels) in 2002 to that in 2007?
Your response must be concise. 1.01. What is the ratio of the Net enrolment rate(%) of Australia in 2002 to that in 2007?
Make the answer very short. 0.98. What is the ratio of the Net enrolment rate(%) of Mali in 2002 to that in 2007?
Provide a short and direct response. 0.83. What is the ratio of the Net enrolment rate(%) in Central Europe in 2002 to that in 2009?
Give a very brief answer. 1.01. What is the ratio of the Net enrolment rate(%) of Europe(all income levels) in 2002 to that in 2009?
Provide a short and direct response. 1.01. What is the ratio of the Net enrolment rate(%) of Australia in 2002 to that in 2009?
Offer a terse response. 0.98. What is the ratio of the Net enrolment rate(%) of Mali in 2002 to that in 2009?
Offer a terse response. 0.77. What is the ratio of the Net enrolment rate(%) in Central Europe in 2003 to that in 2004?
Your answer should be very brief. 1. What is the ratio of the Net enrolment rate(%) in Mali in 2003 to that in 2004?
Give a very brief answer. 0.95. What is the ratio of the Net enrolment rate(%) in Central Europe in 2003 to that in 2005?
Your response must be concise. 1.01. What is the ratio of the Net enrolment rate(%) in Europe(all income levels) in 2003 to that in 2005?
Your answer should be very brief. 1.01. What is the ratio of the Net enrolment rate(%) of Australia in 2003 to that in 2005?
Your response must be concise. 1. What is the ratio of the Net enrolment rate(%) of Mali in 2003 to that in 2005?
Ensure brevity in your answer.  0.89. What is the ratio of the Net enrolment rate(%) in Central Europe in 2003 to that in 2006?
Make the answer very short. 1.01. What is the ratio of the Net enrolment rate(%) of Europe(all income levels) in 2003 to that in 2006?
Provide a short and direct response. 1.01. What is the ratio of the Net enrolment rate(%) of Mali in 2003 to that in 2006?
Offer a very short reply. 0.87. What is the ratio of the Net enrolment rate(%) in Central Europe in 2003 to that in 2007?
Keep it short and to the point. 1.01. What is the ratio of the Net enrolment rate(%) of Europe(all income levels) in 2003 to that in 2007?
Offer a very short reply. 1.01. What is the ratio of the Net enrolment rate(%) of Australia in 2003 to that in 2007?
Offer a very short reply. 0.98. What is the ratio of the Net enrolment rate(%) in Mali in 2003 to that in 2007?
Keep it short and to the point. 0.83. What is the ratio of the Net enrolment rate(%) in Central Europe in 2003 to that in 2009?
Ensure brevity in your answer.  1.01. What is the ratio of the Net enrolment rate(%) in Australia in 2003 to that in 2009?
Your answer should be compact. 0.98. What is the ratio of the Net enrolment rate(%) of Mali in 2003 to that in 2009?
Your response must be concise. 0.77. What is the ratio of the Net enrolment rate(%) of Central Europe in 2004 to that in 2005?
Your answer should be compact. 1. What is the ratio of the Net enrolment rate(%) of Europe(all income levels) in 2004 to that in 2005?
Provide a succinct answer. 1.01. What is the ratio of the Net enrolment rate(%) of Australia in 2004 to that in 2005?
Provide a succinct answer. 1. What is the ratio of the Net enrolment rate(%) in Mali in 2004 to that in 2005?
Offer a terse response. 0.94. What is the ratio of the Net enrolment rate(%) in Central Europe in 2004 to that in 2006?
Provide a succinct answer. 1.01. What is the ratio of the Net enrolment rate(%) in Europe(all income levels) in 2004 to that in 2006?
Keep it short and to the point. 1.01. What is the ratio of the Net enrolment rate(%) of Australia in 2004 to that in 2006?
Provide a short and direct response. 1. What is the ratio of the Net enrolment rate(%) in Mali in 2004 to that in 2006?
Offer a terse response. 0.91. What is the ratio of the Net enrolment rate(%) in Central Europe in 2004 to that in 2007?
Provide a succinct answer. 1.01. What is the ratio of the Net enrolment rate(%) of Europe(all income levels) in 2004 to that in 2007?
Your answer should be compact. 1.01. What is the ratio of the Net enrolment rate(%) of Australia in 2004 to that in 2007?
Provide a succinct answer. 0.98. What is the ratio of the Net enrolment rate(%) in Mali in 2004 to that in 2007?
Your answer should be compact. 0.87. What is the ratio of the Net enrolment rate(%) in Central Europe in 2004 to that in 2009?
Your response must be concise. 1.01. What is the ratio of the Net enrolment rate(%) of Australia in 2004 to that in 2009?
Make the answer very short. 0.98. What is the ratio of the Net enrolment rate(%) in Mali in 2004 to that in 2009?
Provide a short and direct response. 0.81. What is the ratio of the Net enrolment rate(%) of Mali in 2005 to that in 2006?
Your response must be concise. 0.97. What is the ratio of the Net enrolment rate(%) in Central Europe in 2005 to that in 2007?
Give a very brief answer. 1. What is the ratio of the Net enrolment rate(%) in Australia in 2005 to that in 2007?
Your response must be concise. 0.98. What is the ratio of the Net enrolment rate(%) of Mali in 2005 to that in 2007?
Your answer should be compact. 0.93. What is the ratio of the Net enrolment rate(%) in Central Europe in 2005 to that in 2009?
Provide a succinct answer. 1. What is the ratio of the Net enrolment rate(%) in Australia in 2005 to that in 2009?
Offer a terse response. 0.98. What is the ratio of the Net enrolment rate(%) in Mali in 2005 to that in 2009?
Offer a very short reply. 0.87. What is the ratio of the Net enrolment rate(%) in Central Europe in 2006 to that in 2007?
Provide a short and direct response. 1. What is the ratio of the Net enrolment rate(%) in Europe(all income levels) in 2006 to that in 2007?
Make the answer very short. 1. What is the ratio of the Net enrolment rate(%) of Australia in 2006 to that in 2007?
Keep it short and to the point. 0.98. What is the ratio of the Net enrolment rate(%) of Mali in 2006 to that in 2007?
Your answer should be compact. 0.96. What is the ratio of the Net enrolment rate(%) in Central Europe in 2006 to that in 2009?
Provide a short and direct response. 1. What is the ratio of the Net enrolment rate(%) of Australia in 2006 to that in 2009?
Your response must be concise. 0.98. What is the ratio of the Net enrolment rate(%) in Mali in 2006 to that in 2009?
Give a very brief answer. 0.89. What is the ratio of the Net enrolment rate(%) of Mali in 2007 to that in 2009?
Make the answer very short. 0.93. What is the difference between the highest and the second highest Net enrolment rate(%) in Central Europe?
Ensure brevity in your answer.  0.11. What is the difference between the highest and the second highest Net enrolment rate(%) of Europe(all income levels)?
Your answer should be compact. 0.25. What is the difference between the highest and the second highest Net enrolment rate(%) of Australia?
Offer a terse response. 0.45. What is the difference between the highest and the second highest Net enrolment rate(%) in Mali?
Your answer should be very brief. 4.31. What is the difference between the highest and the lowest Net enrolment rate(%) in Central Europe?
Your answer should be very brief. 1.27. What is the difference between the highest and the lowest Net enrolment rate(%) in Europe(all income levels)?
Keep it short and to the point. 1.25. What is the difference between the highest and the lowest Net enrolment rate(%) of Australia?
Offer a very short reply. 2.33. What is the difference between the highest and the lowest Net enrolment rate(%) of Mali?
Your answer should be compact. 14.35. 